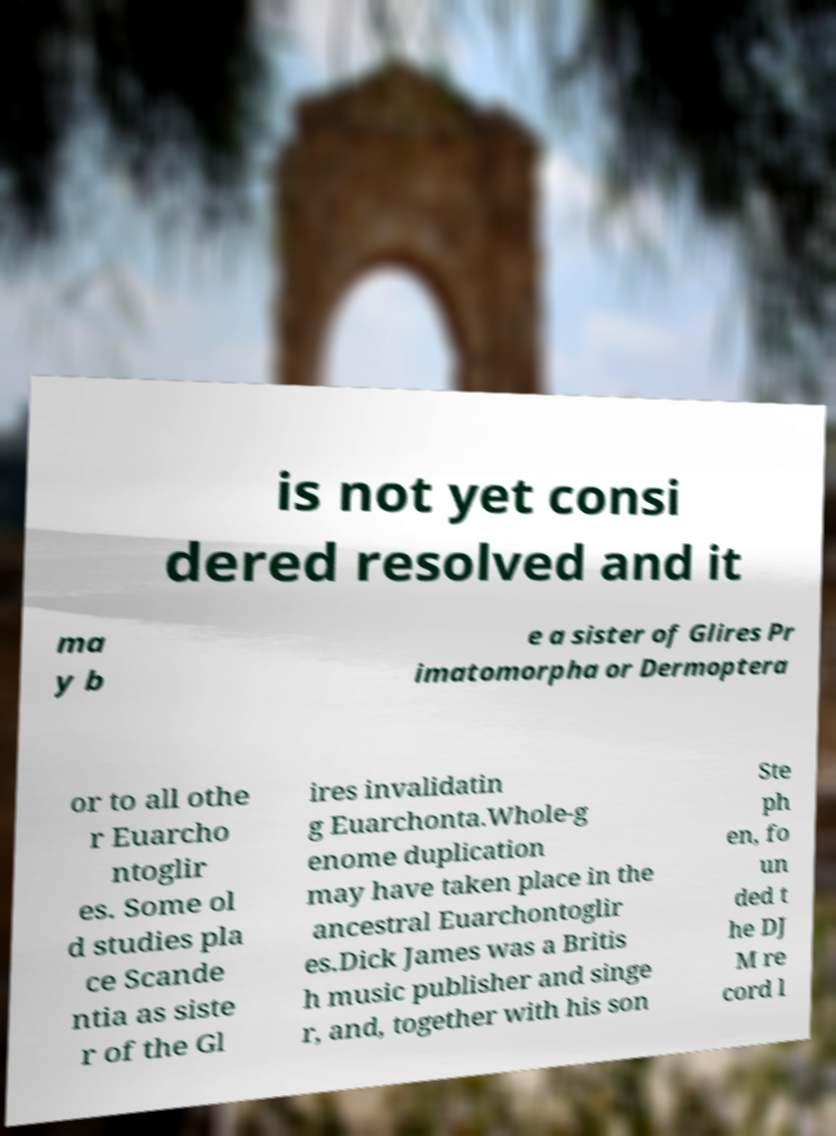Please identify and transcribe the text found in this image. is not yet consi dered resolved and it ma y b e a sister of Glires Pr imatomorpha or Dermoptera or to all othe r Euarcho ntoglir es. Some ol d studies pla ce Scande ntia as siste r of the Gl ires invalidatin g Euarchonta.Whole-g enome duplication may have taken place in the ancestral Euarchontoglir es.Dick James was a Britis h music publisher and singe r, and, together with his son Ste ph en, fo un ded t he DJ M re cord l 